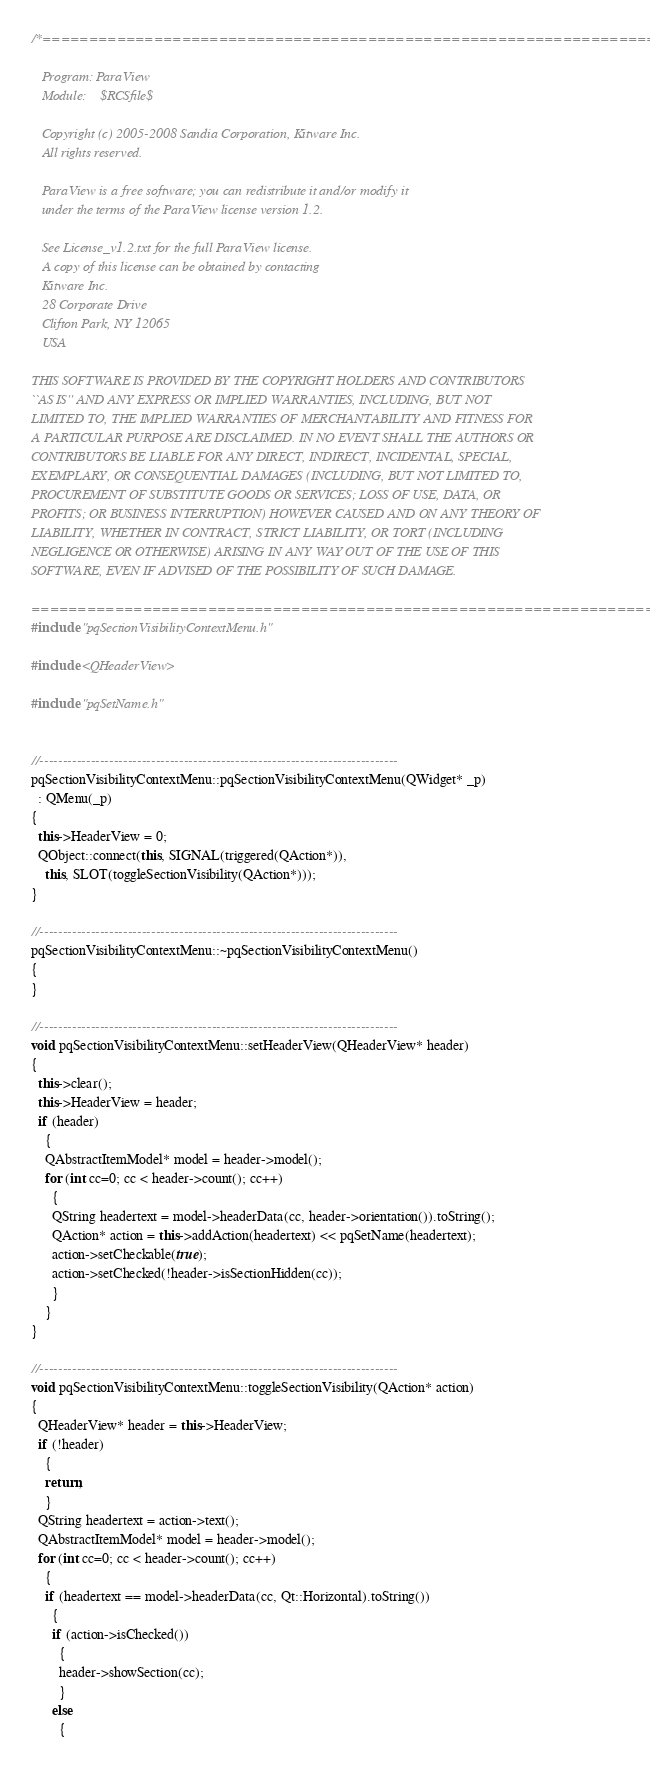Convert code to text. <code><loc_0><loc_0><loc_500><loc_500><_C++_>/*=========================================================================

   Program: ParaView
   Module:    $RCSfile$

   Copyright (c) 2005-2008 Sandia Corporation, Kitware Inc.
   All rights reserved.

   ParaView is a free software; you can redistribute it and/or modify it
   under the terms of the ParaView license version 1.2. 

   See License_v1.2.txt for the full ParaView license.
   A copy of this license can be obtained by contacting
   Kitware Inc.
   28 Corporate Drive
   Clifton Park, NY 12065
   USA

THIS SOFTWARE IS PROVIDED BY THE COPYRIGHT HOLDERS AND CONTRIBUTORS
``AS IS'' AND ANY EXPRESS OR IMPLIED WARRANTIES, INCLUDING, BUT NOT
LIMITED TO, THE IMPLIED WARRANTIES OF MERCHANTABILITY AND FITNESS FOR
A PARTICULAR PURPOSE ARE DISCLAIMED. IN NO EVENT SHALL THE AUTHORS OR
CONTRIBUTORS BE LIABLE FOR ANY DIRECT, INDIRECT, INCIDENTAL, SPECIAL,
EXEMPLARY, OR CONSEQUENTIAL DAMAGES (INCLUDING, BUT NOT LIMITED TO,
PROCUREMENT OF SUBSTITUTE GOODS OR SERVICES; LOSS OF USE, DATA, OR
PROFITS; OR BUSINESS INTERRUPTION) HOWEVER CAUSED AND ON ANY THEORY OF
LIABILITY, WHETHER IN CONTRACT, STRICT LIABILITY, OR TORT (INCLUDING
NEGLIGENCE OR OTHERWISE) ARISING IN ANY WAY OUT OF THE USE OF THIS
SOFTWARE, EVEN IF ADVISED OF THE POSSIBILITY OF SUCH DAMAGE.

=========================================================================*/
#include "pqSectionVisibilityContextMenu.h"

#include <QHeaderView>

#include "pqSetName.h"


//-----------------------------------------------------------------------------
pqSectionVisibilityContextMenu::pqSectionVisibilityContextMenu(QWidget* _p)
  : QMenu(_p)
{
  this->HeaderView = 0;
  QObject::connect(this, SIGNAL(triggered(QAction*)),
    this, SLOT(toggleSectionVisibility(QAction*)));
}

//-----------------------------------------------------------------------------
pqSectionVisibilityContextMenu::~pqSectionVisibilityContextMenu()
{
}

//-----------------------------------------------------------------------------
void pqSectionVisibilityContextMenu::setHeaderView(QHeaderView* header)
{
  this->clear();
  this->HeaderView = header;
  if (header)
    {
    QAbstractItemModel* model = header->model();
    for (int cc=0; cc < header->count(); cc++)
      {
      QString headertext = model->headerData(cc, header->orientation()).toString();
      QAction* action = this->addAction(headertext) << pqSetName(headertext);
      action->setCheckable(true);
      action->setChecked(!header->isSectionHidden(cc));
      }
    }
}

//-----------------------------------------------------------------------------
void pqSectionVisibilityContextMenu::toggleSectionVisibility(QAction* action)
{
  QHeaderView* header = this->HeaderView;
  if (!header)
    {
    return;
    }
  QString headertext = action->text();
  QAbstractItemModel* model = header->model();
  for (int cc=0; cc < header->count(); cc++)
    {
    if (headertext == model->headerData(cc, Qt::Horizontal).toString())
      {
      if (action->isChecked())
        {
        header->showSection(cc);
        }
      else
        {</code> 